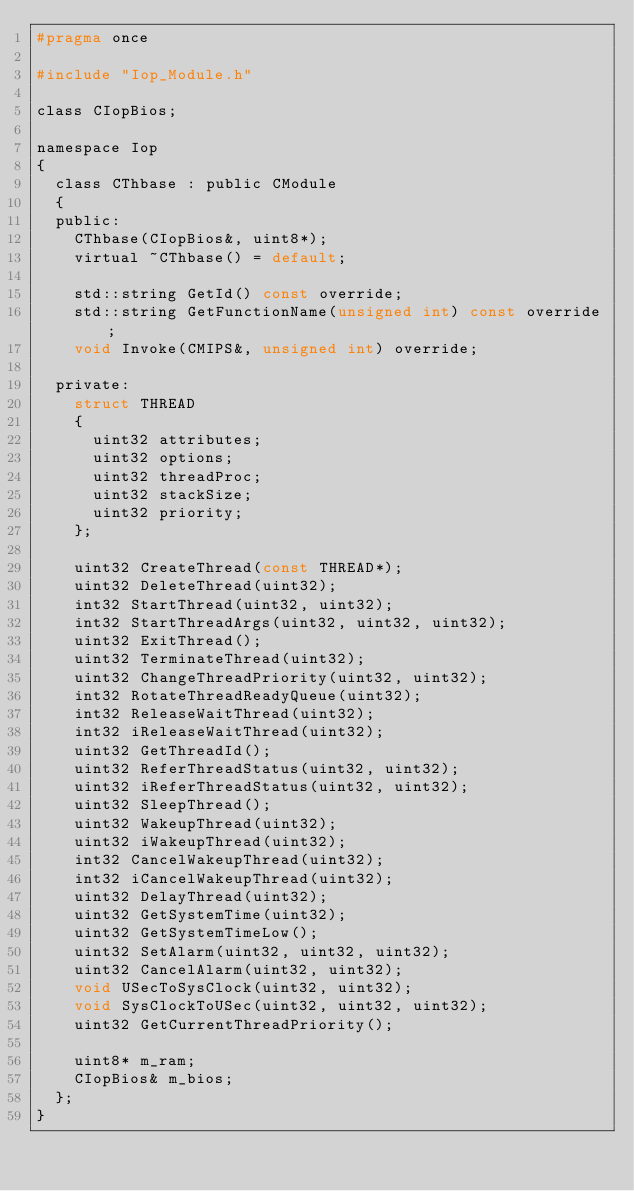<code> <loc_0><loc_0><loc_500><loc_500><_C_>#pragma once

#include "Iop_Module.h"

class CIopBios;

namespace Iop
{
	class CThbase : public CModule
	{
	public:
		CThbase(CIopBios&, uint8*);
		virtual ~CThbase() = default;

		std::string GetId() const override;
		std::string GetFunctionName(unsigned int) const override;
		void Invoke(CMIPS&, unsigned int) override;

	private:
		struct THREAD
		{
			uint32 attributes;
			uint32 options;
			uint32 threadProc;
			uint32 stackSize;
			uint32 priority;
		};

		uint32 CreateThread(const THREAD*);
		uint32 DeleteThread(uint32);
		int32 StartThread(uint32, uint32);
		int32 StartThreadArgs(uint32, uint32, uint32);
		uint32 ExitThread();
		uint32 TerminateThread(uint32);
		uint32 ChangeThreadPriority(uint32, uint32);
		int32 RotateThreadReadyQueue(uint32);
		int32 ReleaseWaitThread(uint32);
		int32 iReleaseWaitThread(uint32);
		uint32 GetThreadId();
		uint32 ReferThreadStatus(uint32, uint32);
		uint32 iReferThreadStatus(uint32, uint32);
		uint32 SleepThread();
		uint32 WakeupThread(uint32);
		uint32 iWakeupThread(uint32);
		int32 CancelWakeupThread(uint32);
		int32 iCancelWakeupThread(uint32);
		uint32 DelayThread(uint32);
		uint32 GetSystemTime(uint32);
		uint32 GetSystemTimeLow();
		uint32 SetAlarm(uint32, uint32, uint32);
		uint32 CancelAlarm(uint32, uint32);
		void USecToSysClock(uint32, uint32);
		void SysClockToUSec(uint32, uint32, uint32);
		uint32 GetCurrentThreadPriority();

		uint8* m_ram;
		CIopBios& m_bios;
	};
}
</code> 